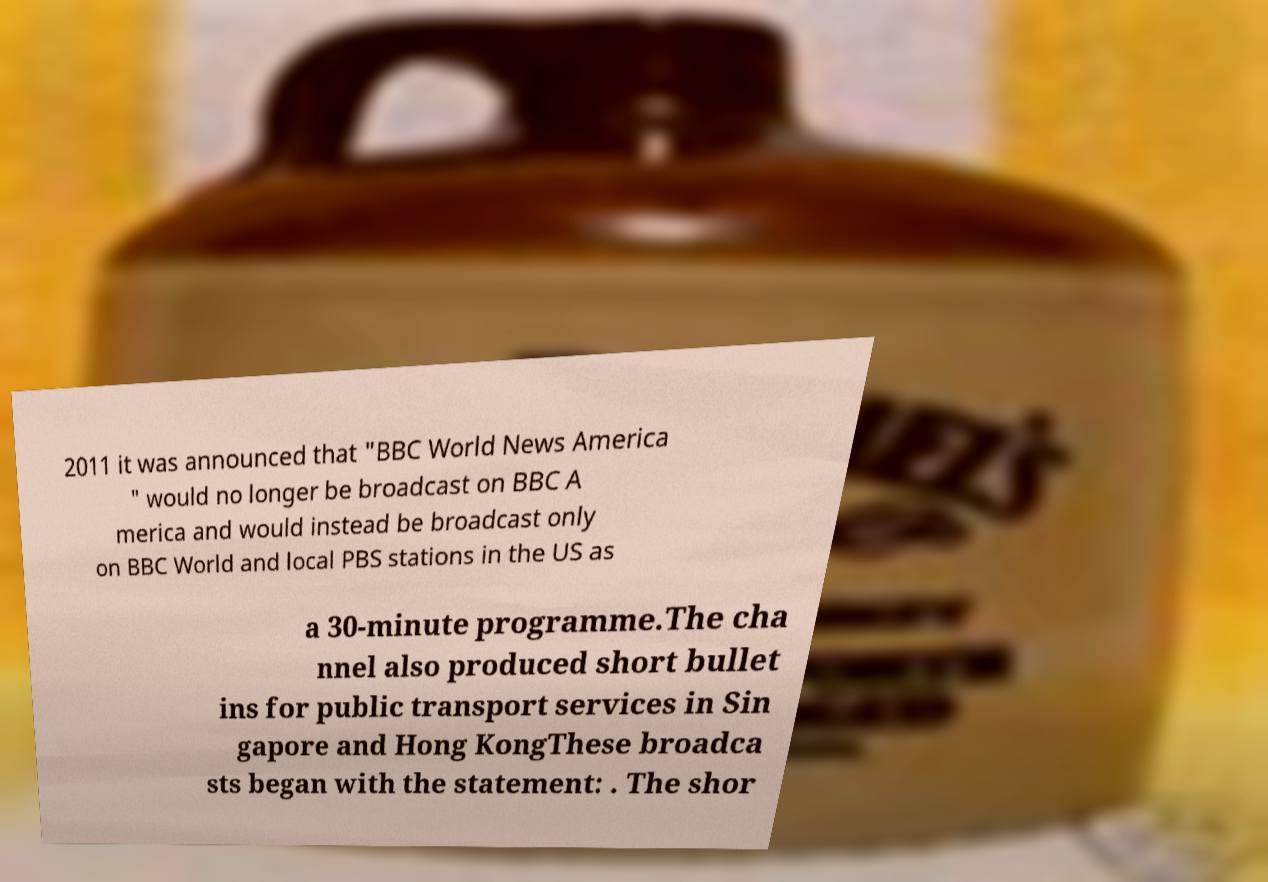Could you assist in decoding the text presented in this image and type it out clearly? 2011 it was announced that "BBC World News America " would no longer be broadcast on BBC A merica and would instead be broadcast only on BBC World and local PBS stations in the US as a 30-minute programme.The cha nnel also produced short bullet ins for public transport services in Sin gapore and Hong KongThese broadca sts began with the statement: . The shor 